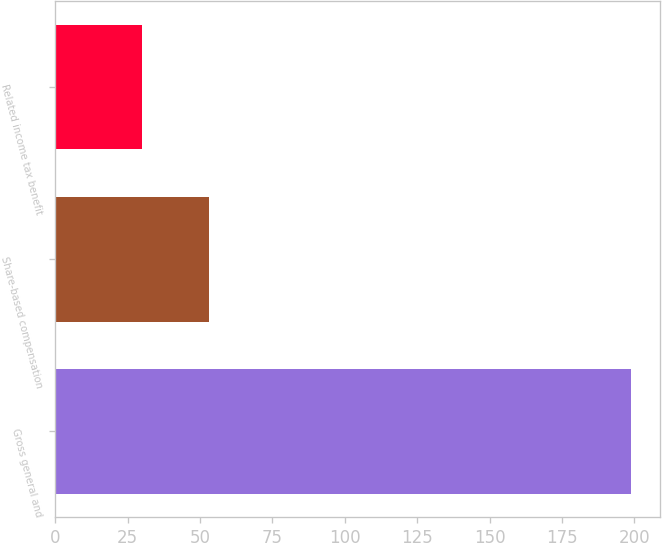Convert chart. <chart><loc_0><loc_0><loc_500><loc_500><bar_chart><fcel>Gross general and<fcel>Share-based compensation<fcel>Related income tax benefit<nl><fcel>199<fcel>53<fcel>30<nl></chart> 